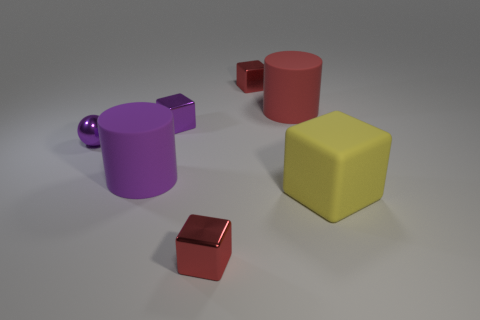Is there any other thing that is the same size as the purple rubber object?
Provide a short and direct response. Yes. How many tiny objects are red metallic cubes or red matte things?
Ensure brevity in your answer.  2. Is the number of red cylinders less than the number of metallic cubes?
Ensure brevity in your answer.  Yes. What is the color of the other big thing that is the same shape as the purple matte thing?
Provide a short and direct response. Red. Is there any other thing that is the same shape as the large purple object?
Give a very brief answer. Yes. Is the number of gray spheres greater than the number of big rubber things?
Ensure brevity in your answer.  No. How many other objects are the same material as the purple block?
Provide a succinct answer. 3. What shape is the red object that is to the right of the metallic object behind the big cylinder that is right of the purple metallic cube?
Your response must be concise. Cylinder. Are there fewer yellow things behind the purple block than purple matte things that are behind the tiny metal sphere?
Give a very brief answer. No. Is there a rubber block of the same color as the metallic sphere?
Provide a succinct answer. No. 